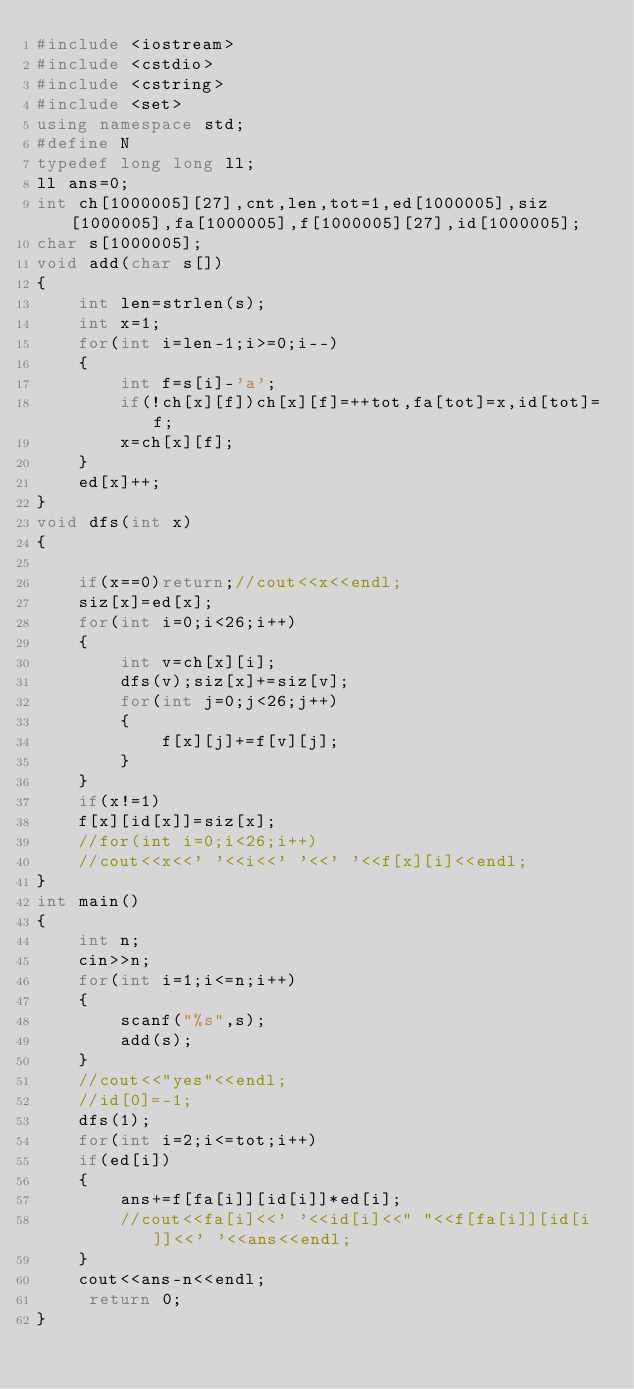Convert code to text. <code><loc_0><loc_0><loc_500><loc_500><_C++_>#include <iostream>
#include <cstdio>
#include <cstring>
#include <set>
using namespace std;
#define N 
typedef long long ll;
ll ans=0;
int ch[1000005][27],cnt,len,tot=1,ed[1000005],siz[1000005],fa[1000005],f[1000005][27],id[1000005];
char s[1000005];
void add(char s[])
{
	int len=strlen(s);
	int x=1;
	for(int i=len-1;i>=0;i--)
	{
		int f=s[i]-'a';
		if(!ch[x][f])ch[x][f]=++tot,fa[tot]=x,id[tot]=f;
		x=ch[x][f];
	}
	ed[x]++;
}
void dfs(int x)
{
	
	if(x==0)return;//cout<<x<<endl;
	siz[x]=ed[x];
	for(int i=0;i<26;i++)
	{
		int v=ch[x][i];
		dfs(v);siz[x]+=siz[v];
		for(int j=0;j<26;j++)
		{
			f[x][j]+=f[v][j];
		}	
	}
	if(x!=1)
	f[x][id[x]]=siz[x];
	//for(int i=0;i<26;i++)
	//cout<<x<<' '<<i<<' '<<' '<<f[x][i]<<endl;
}
int main()
{
	int n;
	cin>>n;
	for(int i=1;i<=n;i++)
	{
		scanf("%s",s);
		add(s);
	}
	//cout<<"yes"<<endl;
	//id[0]=-1;
	dfs(1);
	for(int i=2;i<=tot;i++)	
	if(ed[i])
	{
		ans+=f[fa[i]][id[i]]*ed[i];
		//cout<<fa[i]<<' '<<id[i]<<" "<<f[fa[i]][id[i]]<<' '<<ans<<endl;
	}
	cout<<ans-n<<endl;
     return 0;
} </code> 